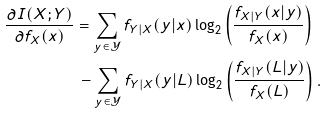<formula> <loc_0><loc_0><loc_500><loc_500>\frac { \partial I ( X ; Y ) } { \partial f _ { X } ( x ) } & = \sum _ { y \in \mathcal { Y } } f _ { Y | X } ( y | x ) \log _ { 2 } \left ( \frac { f _ { X | Y } ( x | y ) } { f _ { X } ( x ) } \right ) \\ & \, - \sum _ { y \in \mathcal { Y } } f _ { Y | X } ( y | L ) \log _ { 2 } \left ( \frac { f _ { X | Y } ( L | y ) } { f _ { X } ( L ) } \right ) .</formula> 